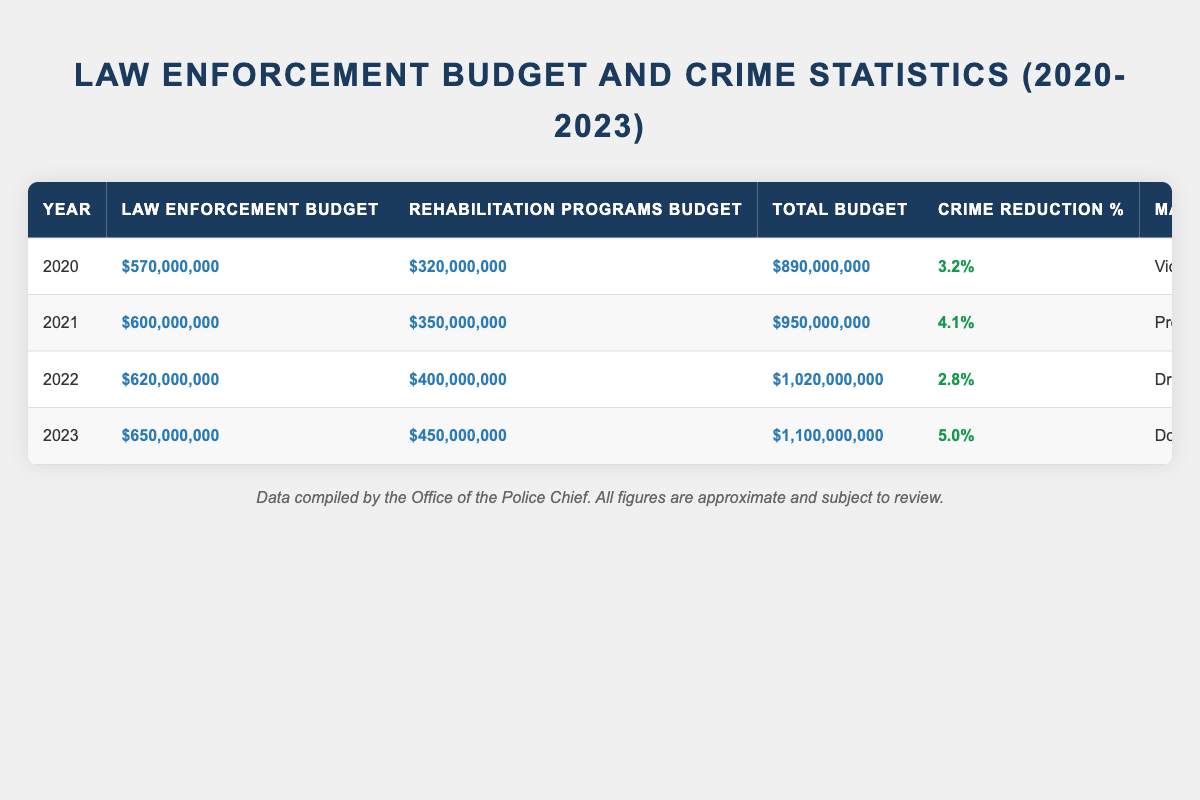What was the total budget for law enforcement in 2023? In 2023, the budget allocation for law enforcement is provided in the table as $650,000,000.
Answer: $650,000,000 What was the crime reduction percentage in 2022? Looking at the table, the crime reduction percentage for 2022 is noted as 2.8%.
Answer: 2.8% Which year had the highest recorded crime rate? By comparing the recorded crime rates from the table (450 in 2020, 420 in 2021, 410 in 2022, and 390 in 2023), 2020 had the highest recorded crime rate of 450.
Answer: 2020 What was the total budget growth from 2020 to 2023? The total budget in 2020 was $890,000,000 and in 2023 it was $1,100,000,000. The growth is calculated by subtracting 890,000,000 from 1,100,000,000, leading to a total growth of $210,000,000.
Answer: $210,000,000 Was the budget allocation for rehabilitation programs higher than that for law enforcement in 2021? In 2021, the budget allocation for law enforcement was $600,000,000 while for rehabilitation programs it was $350,000,000. This means the law enforcement budget was higher, so the statement is false.
Answer: No Which crime type had the lowest crime reduction percentage? By reviewing the crime reduction percentages for each year, 2022 had the lowest percentage at 2.8% compared to the others (3.2% in 2020, 4.1% in 2021, and 5.0% in 2023).
Answer: Drug-related Offenses What was the average budget allocation for rehabilitation programs from 2020 to 2023? The total budget allocations for rehabilitation programs over four years are $320,000,000 (2020), $350,000,000 (2021), $400,000,000 (2022), and $450,000,000 (2023). Adding these amounts gives $1,820,000,000. Dividing by four years results in an average allocation of $455,000,000.
Answer: $455,000,000 How much was reinvested in community programs in 2023? The amount reinvested in community programs for 2023 is stated in the table as $200,000,000.
Answer: $200,000,000 Which year showed the most significant increase in budget allocation for law enforcement from the previous year? By reviewing the data, the increase from 2021 ($600,000,000) to 2022 ($620,000,000) was $20,000,000, from 2022 to 2023 it was $30,000,000, and from 2020 to 2021 it was $30,000,000 as well. Therefore, the most significant increase was from 2022 to 2023 at $30,000,000.
Answer: 2022 to 2023 What was the relationship between the total budget and the crime reduction percentage over the four years? The total budget increased over the years ($890,000,000 to $1,100,000,000), and the crime reduction percentage fluctuated (3.2%, 4.1%, 2.8%, 5.0%). This reveals no consistent relationship where an increase in total budget directly correlates to an increase in crime reduction percentage.
Answer: No consistent relationship 